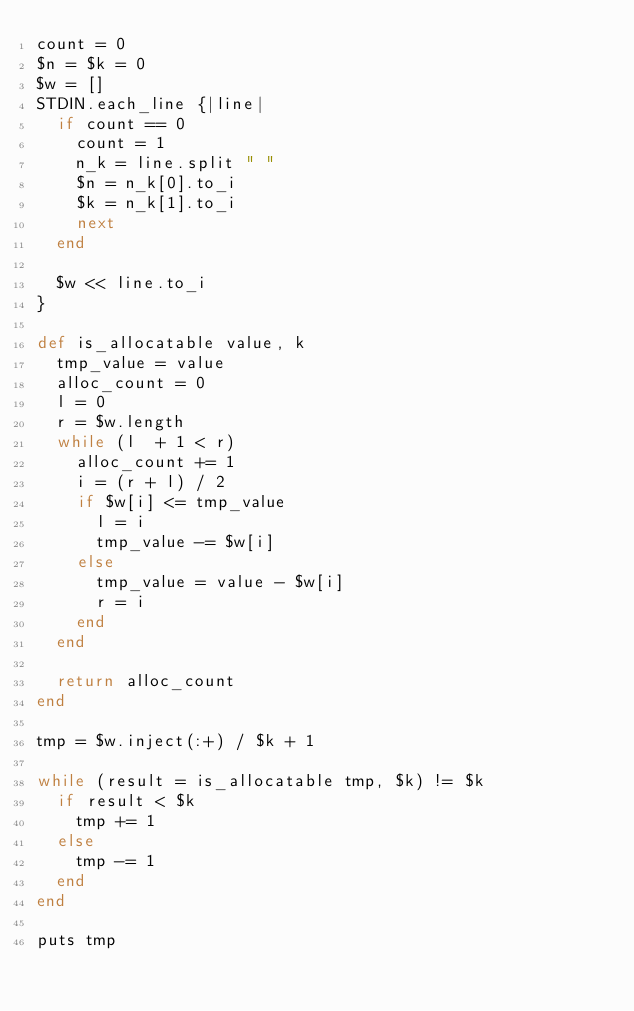Convert code to text. <code><loc_0><loc_0><loc_500><loc_500><_Ruby_>count = 0
$n = $k = 0
$w = []
STDIN.each_line {|line|
  if count == 0
    count = 1
    n_k = line.split " "
    $n = n_k[0].to_i
    $k = n_k[1].to_i
    next
  end

  $w << line.to_i
}

def is_allocatable value, k
  tmp_value = value
  alloc_count = 0
  l = 0
  r = $w.length
  while (l  + 1 < r)
    alloc_count += 1
    i = (r + l) / 2
    if $w[i] <= tmp_value
      l = i
      tmp_value -= $w[i]
    else
      tmp_value = value - $w[i]
      r = i
    end
  end

  return alloc_count
end

tmp = $w.inject(:+) / $k + 1

while (result = is_allocatable tmp, $k) != $k
  if result < $k
    tmp += 1
  else
    tmp -= 1
  end
end

puts tmp

</code> 